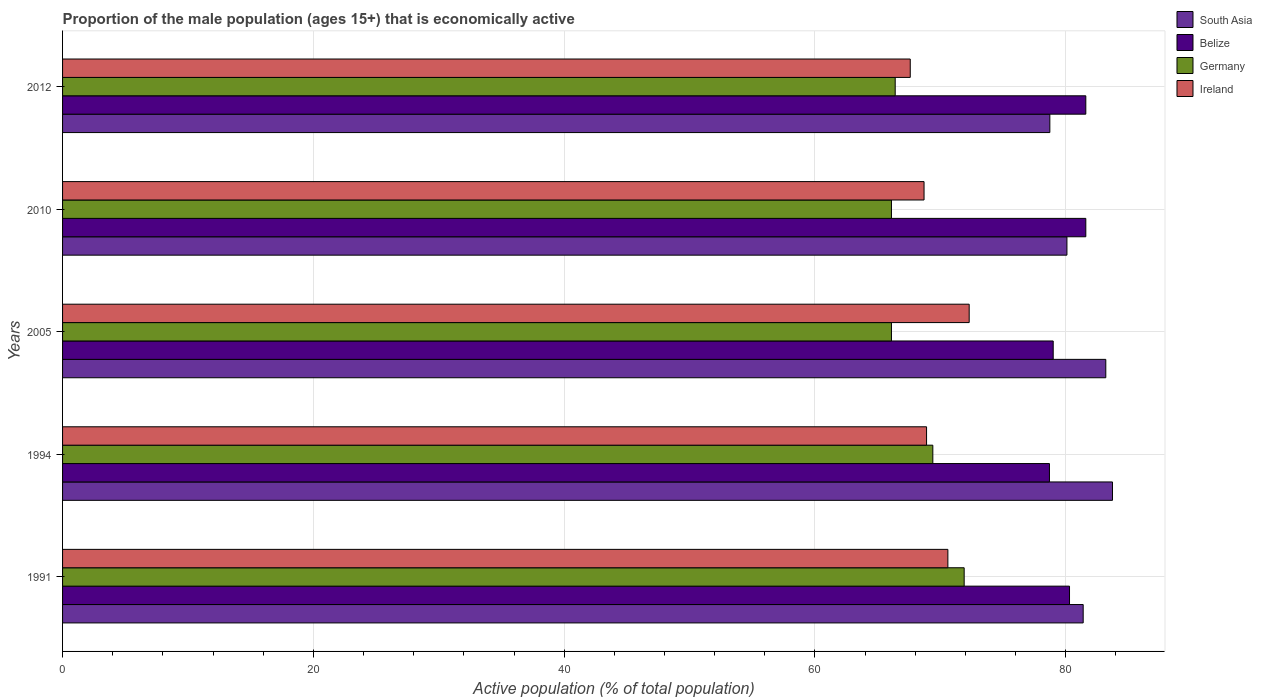How many groups of bars are there?
Your answer should be compact. 5. Are the number of bars per tick equal to the number of legend labels?
Give a very brief answer. Yes. Are the number of bars on each tick of the Y-axis equal?
Offer a terse response. Yes. How many bars are there on the 2nd tick from the bottom?
Ensure brevity in your answer.  4. What is the label of the 3rd group of bars from the top?
Offer a terse response. 2005. In how many cases, is the number of bars for a given year not equal to the number of legend labels?
Provide a succinct answer. 0. What is the proportion of the male population that is economically active in Belize in 1991?
Keep it short and to the point. 80.3. Across all years, what is the maximum proportion of the male population that is economically active in Ireland?
Offer a terse response. 72.3. Across all years, what is the minimum proportion of the male population that is economically active in Belize?
Provide a succinct answer. 78.7. In which year was the proportion of the male population that is economically active in Ireland maximum?
Keep it short and to the point. 2005. What is the total proportion of the male population that is economically active in South Asia in the graph?
Give a very brief answer. 407.14. What is the difference between the proportion of the male population that is economically active in Germany in 1991 and that in 2005?
Ensure brevity in your answer.  5.8. What is the difference between the proportion of the male population that is economically active in Germany in 2010 and the proportion of the male population that is economically active in Ireland in 1991?
Keep it short and to the point. -4.5. What is the average proportion of the male population that is economically active in Ireland per year?
Give a very brief answer. 69.62. In the year 2012, what is the difference between the proportion of the male population that is economically active in Germany and proportion of the male population that is economically active in Ireland?
Your response must be concise. -1.2. In how many years, is the proportion of the male population that is economically active in Belize greater than 24 %?
Your response must be concise. 5. What is the ratio of the proportion of the male population that is economically active in Germany in 1991 to that in 2010?
Your answer should be compact. 1.09. What is the difference between the highest and the second highest proportion of the male population that is economically active in South Asia?
Offer a very short reply. 0.53. What is the difference between the highest and the lowest proportion of the male population that is economically active in Belize?
Provide a short and direct response. 2.9. Is the sum of the proportion of the male population that is economically active in Ireland in 2005 and 2012 greater than the maximum proportion of the male population that is economically active in South Asia across all years?
Offer a very short reply. Yes. What does the 3rd bar from the top in 2010 represents?
Provide a short and direct response. Belize. What does the 2nd bar from the bottom in 2012 represents?
Offer a very short reply. Belize. How many bars are there?
Provide a succinct answer. 20. How many years are there in the graph?
Your response must be concise. 5. Are the values on the major ticks of X-axis written in scientific E-notation?
Ensure brevity in your answer.  No. How many legend labels are there?
Provide a short and direct response. 4. What is the title of the graph?
Offer a very short reply. Proportion of the male population (ages 15+) that is economically active. Does "Liberia" appear as one of the legend labels in the graph?
Your answer should be compact. No. What is the label or title of the X-axis?
Keep it short and to the point. Active population (% of total population). What is the Active population (% of total population) in South Asia in 1991?
Give a very brief answer. 81.39. What is the Active population (% of total population) of Belize in 1991?
Your answer should be very brief. 80.3. What is the Active population (% of total population) in Germany in 1991?
Offer a terse response. 71.9. What is the Active population (% of total population) of Ireland in 1991?
Ensure brevity in your answer.  70.6. What is the Active population (% of total population) in South Asia in 1994?
Ensure brevity in your answer.  83.73. What is the Active population (% of total population) in Belize in 1994?
Offer a terse response. 78.7. What is the Active population (% of total population) in Germany in 1994?
Offer a very short reply. 69.4. What is the Active population (% of total population) in Ireland in 1994?
Provide a succinct answer. 68.9. What is the Active population (% of total population) of South Asia in 2005?
Give a very brief answer. 83.19. What is the Active population (% of total population) in Belize in 2005?
Offer a very short reply. 79. What is the Active population (% of total population) of Germany in 2005?
Your answer should be compact. 66.1. What is the Active population (% of total population) of Ireland in 2005?
Provide a succinct answer. 72.3. What is the Active population (% of total population) in South Asia in 2010?
Make the answer very short. 80.09. What is the Active population (% of total population) in Belize in 2010?
Provide a short and direct response. 81.6. What is the Active population (% of total population) in Germany in 2010?
Make the answer very short. 66.1. What is the Active population (% of total population) of Ireland in 2010?
Make the answer very short. 68.7. What is the Active population (% of total population) of South Asia in 2012?
Offer a terse response. 78.73. What is the Active population (% of total population) of Belize in 2012?
Give a very brief answer. 81.6. What is the Active population (% of total population) of Germany in 2012?
Offer a very short reply. 66.4. What is the Active population (% of total population) of Ireland in 2012?
Make the answer very short. 67.6. Across all years, what is the maximum Active population (% of total population) in South Asia?
Make the answer very short. 83.73. Across all years, what is the maximum Active population (% of total population) of Belize?
Provide a succinct answer. 81.6. Across all years, what is the maximum Active population (% of total population) of Germany?
Keep it short and to the point. 71.9. Across all years, what is the maximum Active population (% of total population) in Ireland?
Your answer should be compact. 72.3. Across all years, what is the minimum Active population (% of total population) in South Asia?
Offer a very short reply. 78.73. Across all years, what is the minimum Active population (% of total population) of Belize?
Keep it short and to the point. 78.7. Across all years, what is the minimum Active population (% of total population) in Germany?
Give a very brief answer. 66.1. Across all years, what is the minimum Active population (% of total population) in Ireland?
Make the answer very short. 67.6. What is the total Active population (% of total population) of South Asia in the graph?
Provide a succinct answer. 407.14. What is the total Active population (% of total population) of Belize in the graph?
Give a very brief answer. 401.2. What is the total Active population (% of total population) in Germany in the graph?
Provide a succinct answer. 339.9. What is the total Active population (% of total population) of Ireland in the graph?
Provide a succinct answer. 348.1. What is the difference between the Active population (% of total population) of South Asia in 1991 and that in 1994?
Ensure brevity in your answer.  -2.34. What is the difference between the Active population (% of total population) of Germany in 1991 and that in 1994?
Ensure brevity in your answer.  2.5. What is the difference between the Active population (% of total population) in South Asia in 1991 and that in 2005?
Keep it short and to the point. -1.8. What is the difference between the Active population (% of total population) of Belize in 1991 and that in 2005?
Your answer should be compact. 1.3. What is the difference between the Active population (% of total population) in South Asia in 1991 and that in 2010?
Keep it short and to the point. 1.3. What is the difference between the Active population (% of total population) of South Asia in 1991 and that in 2012?
Your answer should be very brief. 2.66. What is the difference between the Active population (% of total population) of Belize in 1991 and that in 2012?
Make the answer very short. -1.3. What is the difference between the Active population (% of total population) of Germany in 1991 and that in 2012?
Provide a succinct answer. 5.5. What is the difference between the Active population (% of total population) in Ireland in 1991 and that in 2012?
Keep it short and to the point. 3. What is the difference between the Active population (% of total population) of South Asia in 1994 and that in 2005?
Give a very brief answer. 0.53. What is the difference between the Active population (% of total population) in South Asia in 1994 and that in 2010?
Ensure brevity in your answer.  3.63. What is the difference between the Active population (% of total population) in Ireland in 1994 and that in 2010?
Your response must be concise. 0.2. What is the difference between the Active population (% of total population) in South Asia in 1994 and that in 2012?
Keep it short and to the point. 4.99. What is the difference between the Active population (% of total population) in South Asia in 2005 and that in 2010?
Provide a short and direct response. 3.1. What is the difference between the Active population (% of total population) of Belize in 2005 and that in 2010?
Your response must be concise. -2.6. What is the difference between the Active population (% of total population) in Ireland in 2005 and that in 2010?
Your answer should be compact. 3.6. What is the difference between the Active population (% of total population) in South Asia in 2005 and that in 2012?
Keep it short and to the point. 4.46. What is the difference between the Active population (% of total population) of Germany in 2005 and that in 2012?
Your answer should be compact. -0.3. What is the difference between the Active population (% of total population) in South Asia in 2010 and that in 2012?
Offer a very short reply. 1.36. What is the difference between the Active population (% of total population) of Belize in 2010 and that in 2012?
Provide a succinct answer. 0. What is the difference between the Active population (% of total population) of Ireland in 2010 and that in 2012?
Make the answer very short. 1.1. What is the difference between the Active population (% of total population) in South Asia in 1991 and the Active population (% of total population) in Belize in 1994?
Your response must be concise. 2.69. What is the difference between the Active population (% of total population) of South Asia in 1991 and the Active population (% of total population) of Germany in 1994?
Provide a succinct answer. 11.99. What is the difference between the Active population (% of total population) of South Asia in 1991 and the Active population (% of total population) of Ireland in 1994?
Provide a short and direct response. 12.49. What is the difference between the Active population (% of total population) in Germany in 1991 and the Active population (% of total population) in Ireland in 1994?
Make the answer very short. 3. What is the difference between the Active population (% of total population) in South Asia in 1991 and the Active population (% of total population) in Belize in 2005?
Provide a short and direct response. 2.39. What is the difference between the Active population (% of total population) in South Asia in 1991 and the Active population (% of total population) in Germany in 2005?
Offer a very short reply. 15.29. What is the difference between the Active population (% of total population) in South Asia in 1991 and the Active population (% of total population) in Ireland in 2005?
Provide a short and direct response. 9.09. What is the difference between the Active population (% of total population) of Belize in 1991 and the Active population (% of total population) of Germany in 2005?
Your response must be concise. 14.2. What is the difference between the Active population (% of total population) in Germany in 1991 and the Active population (% of total population) in Ireland in 2005?
Make the answer very short. -0.4. What is the difference between the Active population (% of total population) in South Asia in 1991 and the Active population (% of total population) in Belize in 2010?
Offer a very short reply. -0.21. What is the difference between the Active population (% of total population) of South Asia in 1991 and the Active population (% of total population) of Germany in 2010?
Ensure brevity in your answer.  15.29. What is the difference between the Active population (% of total population) in South Asia in 1991 and the Active population (% of total population) in Ireland in 2010?
Offer a terse response. 12.69. What is the difference between the Active population (% of total population) of Belize in 1991 and the Active population (% of total population) of Germany in 2010?
Give a very brief answer. 14.2. What is the difference between the Active population (% of total population) in South Asia in 1991 and the Active population (% of total population) in Belize in 2012?
Your response must be concise. -0.21. What is the difference between the Active population (% of total population) in South Asia in 1991 and the Active population (% of total population) in Germany in 2012?
Make the answer very short. 14.99. What is the difference between the Active population (% of total population) in South Asia in 1991 and the Active population (% of total population) in Ireland in 2012?
Offer a very short reply. 13.79. What is the difference between the Active population (% of total population) of Belize in 1991 and the Active population (% of total population) of Germany in 2012?
Your response must be concise. 13.9. What is the difference between the Active population (% of total population) of Germany in 1991 and the Active population (% of total population) of Ireland in 2012?
Your response must be concise. 4.3. What is the difference between the Active population (% of total population) in South Asia in 1994 and the Active population (% of total population) in Belize in 2005?
Provide a succinct answer. 4.73. What is the difference between the Active population (% of total population) in South Asia in 1994 and the Active population (% of total population) in Germany in 2005?
Your answer should be very brief. 17.63. What is the difference between the Active population (% of total population) of South Asia in 1994 and the Active population (% of total population) of Ireland in 2005?
Provide a short and direct response. 11.43. What is the difference between the Active population (% of total population) of Belize in 1994 and the Active population (% of total population) of Ireland in 2005?
Ensure brevity in your answer.  6.4. What is the difference between the Active population (% of total population) in Germany in 1994 and the Active population (% of total population) in Ireland in 2005?
Ensure brevity in your answer.  -2.9. What is the difference between the Active population (% of total population) in South Asia in 1994 and the Active population (% of total population) in Belize in 2010?
Your response must be concise. 2.13. What is the difference between the Active population (% of total population) of South Asia in 1994 and the Active population (% of total population) of Germany in 2010?
Ensure brevity in your answer.  17.63. What is the difference between the Active population (% of total population) of South Asia in 1994 and the Active population (% of total population) of Ireland in 2010?
Ensure brevity in your answer.  15.03. What is the difference between the Active population (% of total population) in Belize in 1994 and the Active population (% of total population) in Germany in 2010?
Offer a very short reply. 12.6. What is the difference between the Active population (% of total population) of South Asia in 1994 and the Active population (% of total population) of Belize in 2012?
Offer a terse response. 2.13. What is the difference between the Active population (% of total population) of South Asia in 1994 and the Active population (% of total population) of Germany in 2012?
Offer a very short reply. 17.33. What is the difference between the Active population (% of total population) of South Asia in 1994 and the Active population (% of total population) of Ireland in 2012?
Your response must be concise. 16.13. What is the difference between the Active population (% of total population) in Belize in 1994 and the Active population (% of total population) in Ireland in 2012?
Provide a short and direct response. 11.1. What is the difference between the Active population (% of total population) in Germany in 1994 and the Active population (% of total population) in Ireland in 2012?
Offer a very short reply. 1.8. What is the difference between the Active population (% of total population) of South Asia in 2005 and the Active population (% of total population) of Belize in 2010?
Offer a very short reply. 1.59. What is the difference between the Active population (% of total population) in South Asia in 2005 and the Active population (% of total population) in Germany in 2010?
Offer a terse response. 17.09. What is the difference between the Active population (% of total population) in South Asia in 2005 and the Active population (% of total population) in Ireland in 2010?
Offer a terse response. 14.49. What is the difference between the Active population (% of total population) of Belize in 2005 and the Active population (% of total population) of Ireland in 2010?
Your answer should be compact. 10.3. What is the difference between the Active population (% of total population) of Germany in 2005 and the Active population (% of total population) of Ireland in 2010?
Ensure brevity in your answer.  -2.6. What is the difference between the Active population (% of total population) in South Asia in 2005 and the Active population (% of total population) in Belize in 2012?
Offer a terse response. 1.59. What is the difference between the Active population (% of total population) of South Asia in 2005 and the Active population (% of total population) of Germany in 2012?
Your answer should be very brief. 16.79. What is the difference between the Active population (% of total population) of South Asia in 2005 and the Active population (% of total population) of Ireland in 2012?
Your answer should be very brief. 15.59. What is the difference between the Active population (% of total population) of Belize in 2005 and the Active population (% of total population) of Germany in 2012?
Give a very brief answer. 12.6. What is the difference between the Active population (% of total population) in Belize in 2005 and the Active population (% of total population) in Ireland in 2012?
Make the answer very short. 11.4. What is the difference between the Active population (% of total population) of Germany in 2005 and the Active population (% of total population) of Ireland in 2012?
Ensure brevity in your answer.  -1.5. What is the difference between the Active population (% of total population) in South Asia in 2010 and the Active population (% of total population) in Belize in 2012?
Provide a short and direct response. -1.51. What is the difference between the Active population (% of total population) of South Asia in 2010 and the Active population (% of total population) of Germany in 2012?
Your response must be concise. 13.69. What is the difference between the Active population (% of total population) in South Asia in 2010 and the Active population (% of total population) in Ireland in 2012?
Make the answer very short. 12.49. What is the difference between the Active population (% of total population) in Belize in 2010 and the Active population (% of total population) in Germany in 2012?
Provide a short and direct response. 15.2. What is the difference between the Active population (% of total population) of Germany in 2010 and the Active population (% of total population) of Ireland in 2012?
Give a very brief answer. -1.5. What is the average Active population (% of total population) in South Asia per year?
Provide a succinct answer. 81.43. What is the average Active population (% of total population) in Belize per year?
Keep it short and to the point. 80.24. What is the average Active population (% of total population) in Germany per year?
Provide a succinct answer. 67.98. What is the average Active population (% of total population) of Ireland per year?
Your response must be concise. 69.62. In the year 1991, what is the difference between the Active population (% of total population) in South Asia and Active population (% of total population) in Belize?
Your response must be concise. 1.09. In the year 1991, what is the difference between the Active population (% of total population) in South Asia and Active population (% of total population) in Germany?
Give a very brief answer. 9.49. In the year 1991, what is the difference between the Active population (% of total population) in South Asia and Active population (% of total population) in Ireland?
Your answer should be compact. 10.79. In the year 1991, what is the difference between the Active population (% of total population) in Belize and Active population (% of total population) in Germany?
Keep it short and to the point. 8.4. In the year 1991, what is the difference between the Active population (% of total population) in Germany and Active population (% of total population) in Ireland?
Offer a terse response. 1.3. In the year 1994, what is the difference between the Active population (% of total population) of South Asia and Active population (% of total population) of Belize?
Offer a terse response. 5.03. In the year 1994, what is the difference between the Active population (% of total population) of South Asia and Active population (% of total population) of Germany?
Keep it short and to the point. 14.33. In the year 1994, what is the difference between the Active population (% of total population) of South Asia and Active population (% of total population) of Ireland?
Offer a terse response. 14.83. In the year 1994, what is the difference between the Active population (% of total population) in Germany and Active population (% of total population) in Ireland?
Your response must be concise. 0.5. In the year 2005, what is the difference between the Active population (% of total population) of South Asia and Active population (% of total population) of Belize?
Ensure brevity in your answer.  4.19. In the year 2005, what is the difference between the Active population (% of total population) in South Asia and Active population (% of total population) in Germany?
Give a very brief answer. 17.09. In the year 2005, what is the difference between the Active population (% of total population) in South Asia and Active population (% of total population) in Ireland?
Ensure brevity in your answer.  10.89. In the year 2005, what is the difference between the Active population (% of total population) in Belize and Active population (% of total population) in Ireland?
Make the answer very short. 6.7. In the year 2005, what is the difference between the Active population (% of total population) in Germany and Active population (% of total population) in Ireland?
Keep it short and to the point. -6.2. In the year 2010, what is the difference between the Active population (% of total population) of South Asia and Active population (% of total population) of Belize?
Keep it short and to the point. -1.51. In the year 2010, what is the difference between the Active population (% of total population) in South Asia and Active population (% of total population) in Germany?
Make the answer very short. 13.99. In the year 2010, what is the difference between the Active population (% of total population) in South Asia and Active population (% of total population) in Ireland?
Offer a very short reply. 11.39. In the year 2010, what is the difference between the Active population (% of total population) in Germany and Active population (% of total population) in Ireland?
Make the answer very short. -2.6. In the year 2012, what is the difference between the Active population (% of total population) in South Asia and Active population (% of total population) in Belize?
Keep it short and to the point. -2.87. In the year 2012, what is the difference between the Active population (% of total population) of South Asia and Active population (% of total population) of Germany?
Offer a terse response. 12.33. In the year 2012, what is the difference between the Active population (% of total population) of South Asia and Active population (% of total population) of Ireland?
Make the answer very short. 11.13. What is the ratio of the Active population (% of total population) in South Asia in 1991 to that in 1994?
Your answer should be very brief. 0.97. What is the ratio of the Active population (% of total population) in Belize in 1991 to that in 1994?
Keep it short and to the point. 1.02. What is the ratio of the Active population (% of total population) of Germany in 1991 to that in 1994?
Provide a succinct answer. 1.04. What is the ratio of the Active population (% of total population) in Ireland in 1991 to that in 1994?
Keep it short and to the point. 1.02. What is the ratio of the Active population (% of total population) in South Asia in 1991 to that in 2005?
Your answer should be very brief. 0.98. What is the ratio of the Active population (% of total population) of Belize in 1991 to that in 2005?
Offer a terse response. 1.02. What is the ratio of the Active population (% of total population) of Germany in 1991 to that in 2005?
Give a very brief answer. 1.09. What is the ratio of the Active population (% of total population) in Ireland in 1991 to that in 2005?
Provide a short and direct response. 0.98. What is the ratio of the Active population (% of total population) in South Asia in 1991 to that in 2010?
Offer a terse response. 1.02. What is the ratio of the Active population (% of total population) of Belize in 1991 to that in 2010?
Ensure brevity in your answer.  0.98. What is the ratio of the Active population (% of total population) in Germany in 1991 to that in 2010?
Give a very brief answer. 1.09. What is the ratio of the Active population (% of total population) in Ireland in 1991 to that in 2010?
Offer a very short reply. 1.03. What is the ratio of the Active population (% of total population) in South Asia in 1991 to that in 2012?
Your response must be concise. 1.03. What is the ratio of the Active population (% of total population) in Belize in 1991 to that in 2012?
Offer a terse response. 0.98. What is the ratio of the Active population (% of total population) of Germany in 1991 to that in 2012?
Your answer should be very brief. 1.08. What is the ratio of the Active population (% of total population) in Ireland in 1991 to that in 2012?
Your answer should be very brief. 1.04. What is the ratio of the Active population (% of total population) in South Asia in 1994 to that in 2005?
Provide a short and direct response. 1.01. What is the ratio of the Active population (% of total population) of Belize in 1994 to that in 2005?
Offer a terse response. 1. What is the ratio of the Active population (% of total population) of Germany in 1994 to that in 2005?
Give a very brief answer. 1.05. What is the ratio of the Active population (% of total population) in Ireland in 1994 to that in 2005?
Provide a short and direct response. 0.95. What is the ratio of the Active population (% of total population) in South Asia in 1994 to that in 2010?
Provide a short and direct response. 1.05. What is the ratio of the Active population (% of total population) in Belize in 1994 to that in 2010?
Provide a short and direct response. 0.96. What is the ratio of the Active population (% of total population) in Germany in 1994 to that in 2010?
Make the answer very short. 1.05. What is the ratio of the Active population (% of total population) of Ireland in 1994 to that in 2010?
Keep it short and to the point. 1. What is the ratio of the Active population (% of total population) in South Asia in 1994 to that in 2012?
Offer a very short reply. 1.06. What is the ratio of the Active population (% of total population) of Belize in 1994 to that in 2012?
Your answer should be very brief. 0.96. What is the ratio of the Active population (% of total population) of Germany in 1994 to that in 2012?
Make the answer very short. 1.05. What is the ratio of the Active population (% of total population) of Ireland in 1994 to that in 2012?
Make the answer very short. 1.02. What is the ratio of the Active population (% of total population) of South Asia in 2005 to that in 2010?
Provide a succinct answer. 1.04. What is the ratio of the Active population (% of total population) in Belize in 2005 to that in 2010?
Make the answer very short. 0.97. What is the ratio of the Active population (% of total population) of Ireland in 2005 to that in 2010?
Provide a succinct answer. 1.05. What is the ratio of the Active population (% of total population) in South Asia in 2005 to that in 2012?
Your answer should be very brief. 1.06. What is the ratio of the Active population (% of total population) in Belize in 2005 to that in 2012?
Ensure brevity in your answer.  0.97. What is the ratio of the Active population (% of total population) of Germany in 2005 to that in 2012?
Make the answer very short. 1. What is the ratio of the Active population (% of total population) in Ireland in 2005 to that in 2012?
Provide a succinct answer. 1.07. What is the ratio of the Active population (% of total population) of South Asia in 2010 to that in 2012?
Offer a terse response. 1.02. What is the ratio of the Active population (% of total population) in Ireland in 2010 to that in 2012?
Offer a terse response. 1.02. What is the difference between the highest and the second highest Active population (% of total population) in South Asia?
Provide a short and direct response. 0.53. What is the difference between the highest and the second highest Active population (% of total population) of Germany?
Your answer should be very brief. 2.5. What is the difference between the highest and the lowest Active population (% of total population) in South Asia?
Provide a short and direct response. 4.99. What is the difference between the highest and the lowest Active population (% of total population) in Belize?
Offer a terse response. 2.9. 